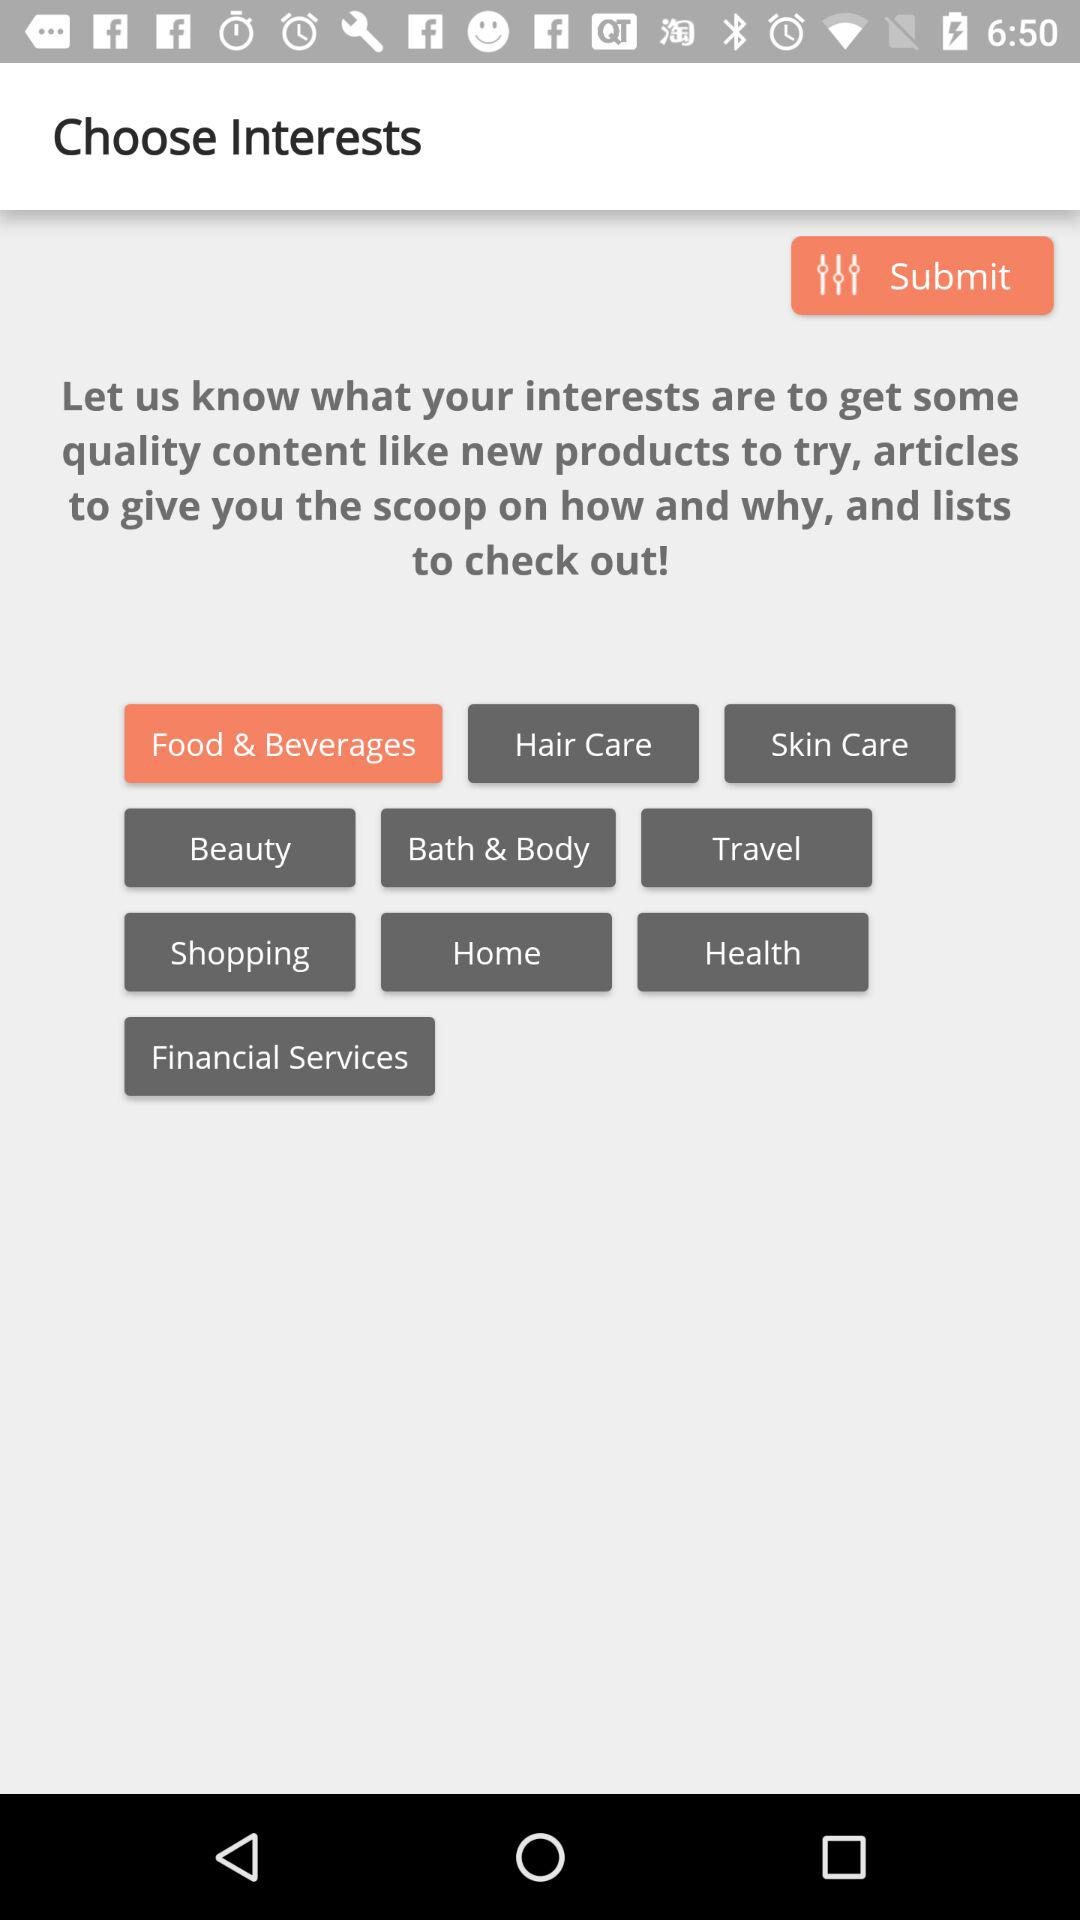How many interests can I select?
Answer the question using a single word or phrase. 10 